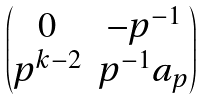<formula> <loc_0><loc_0><loc_500><loc_500>\begin{pmatrix} 0 & - p ^ { - 1 } \\ p ^ { k - 2 } & p ^ { - 1 } a _ { p } \end{pmatrix}</formula> 